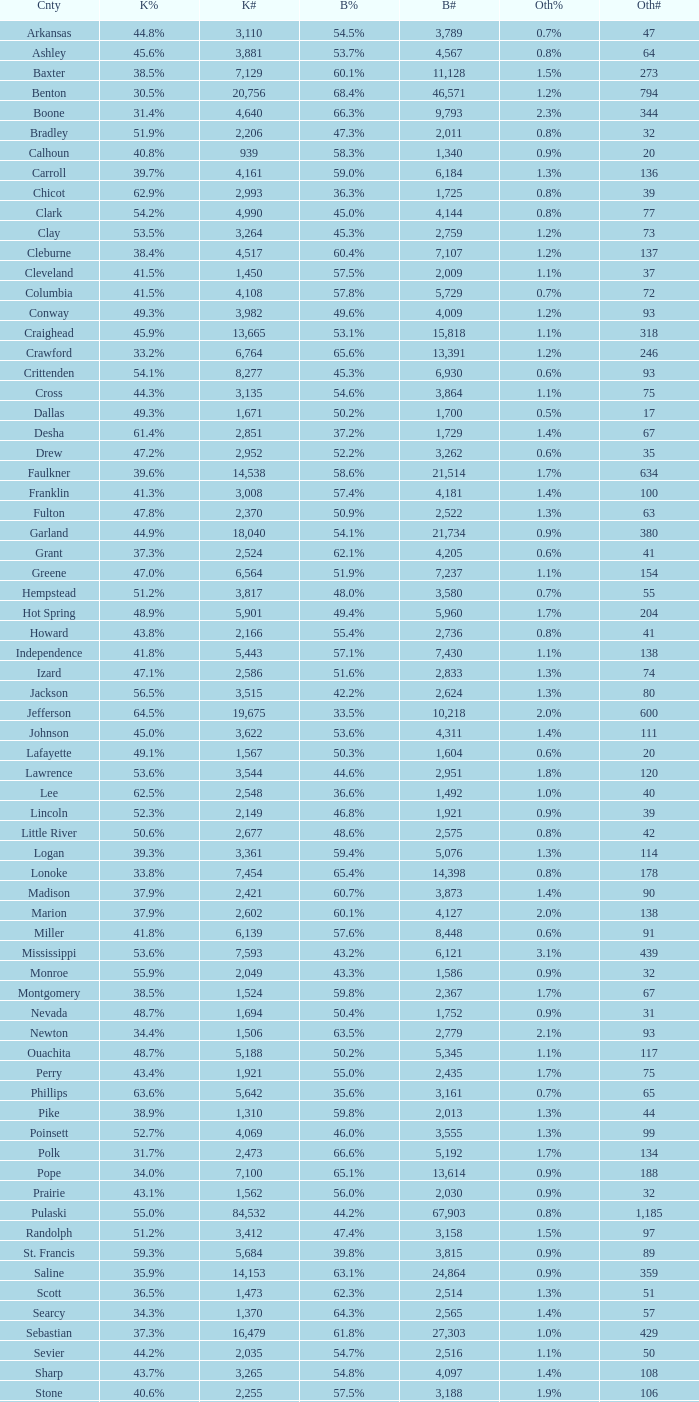What is the highest Bush#, when Others% is "1.7%", when Others# is less than 75, and when Kerry# is greater than 1,524? None. 